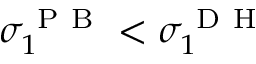<formula> <loc_0><loc_0><loc_500><loc_500>\sigma _ { 1 } ^ { P B } < \sigma _ { 1 } ^ { D H }</formula> 